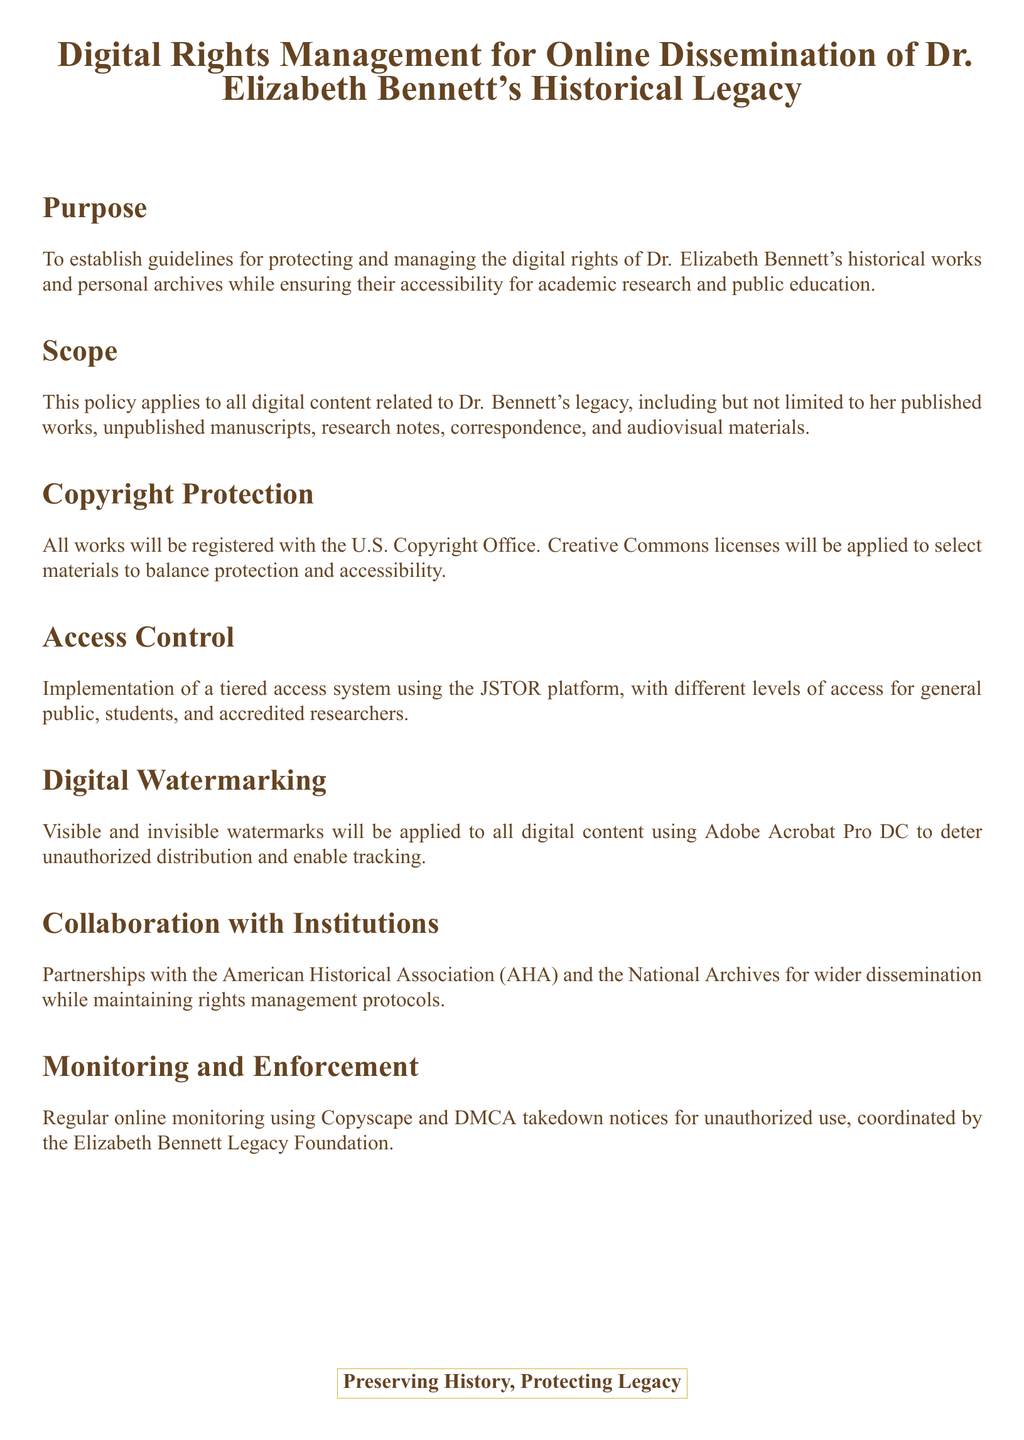What is the purpose of the policy? The purpose is outlined in the document as establishing guidelines for protecting and managing digital rights while ensuring accessibility.
Answer: To establish guidelines for protecting and managing the digital rights of Dr. Elizabeth Bennett's historical works and personal archives while ensuring their accessibility for academic research and public education What does the scope cover? The scope defines what types of digital content are included under the policy.
Answer: All digital content related to Dr. Bennett's legacy, including but not limited to her published works, unpublished manuscripts, research notes, correspondence, and audiovisual materials Where will works be registered? The registration location for the works under this policy is specified in the document.
Answer: U.S. Copyright Office What type of licenses will be applied? The document specifies the type of licenses used for some materials.
Answer: Creative Commons licenses What is the primary monitoring tool mentioned? The document identifies the primary tool used for monitoring unauthorized use of content.
Answer: Copyscape What organization is mentioned for collaboration? The document lists one of the organizations that will collaborate for rights management.
Answer: American Historical Association (AHA) How will digital content be protected against unauthorized distribution? The method mentioned for deterrence of unauthorized distribution is described in the document.
Answer: Digital Watermarking What tiered access system will be implemented? The document states the platform that will be used for tiered access.
Answer: JSTOR What is the motto at the end of the document? The motto is a phrase that encapsulates the essence of the policy and is provided towards the conclusion of the document.
Answer: Preserving History, Protecting Legacy 